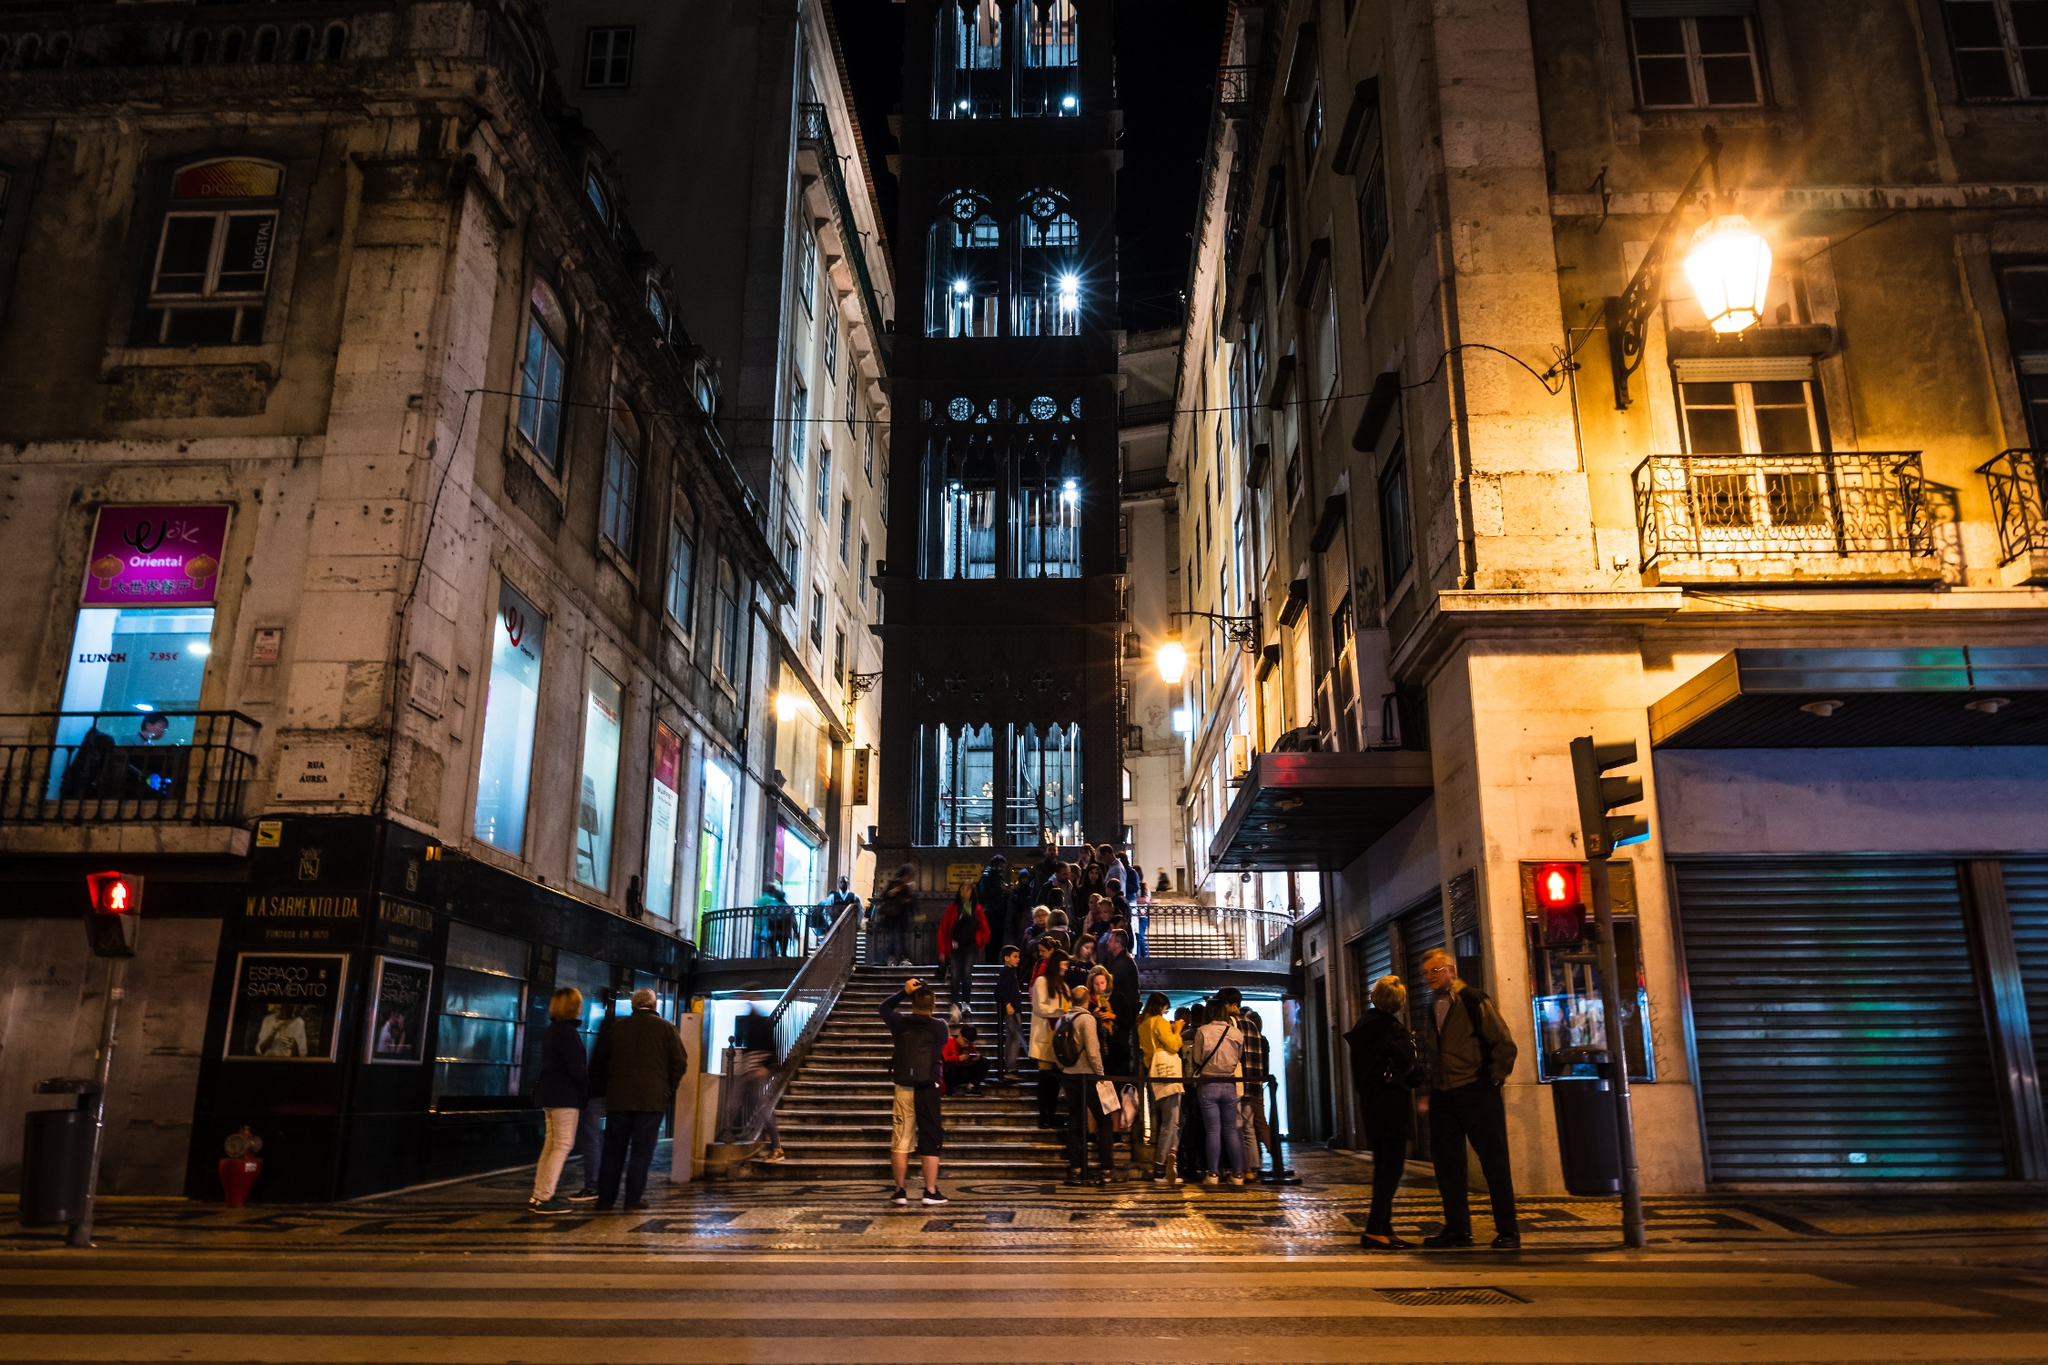Imagine a fantastical story involving this location. In a world where ancient structures harbor mystical powers, the Santa Justa Lift stands as a gateway to a parallel universe. Every night, as the clock strikes midnight, the elevator's lights flicker to life with an ethereal glow. Those brave enough to board the lift at this enchanted hour find themselves transported to a realm where the past and future merge. In this extraordinary place, medieval knights and futuristic robots coexist, and the very fabric of reality is woven with magic and technology. The lift is guarded by an ancient order of timekeepers, who ensure that the balance between the realms is maintained. One night, a young adventurer discovers an old manuscript detailing the legend of the lift and sets out on a daring journey, uncovering secrets that could alter the course of both worlds forever. 